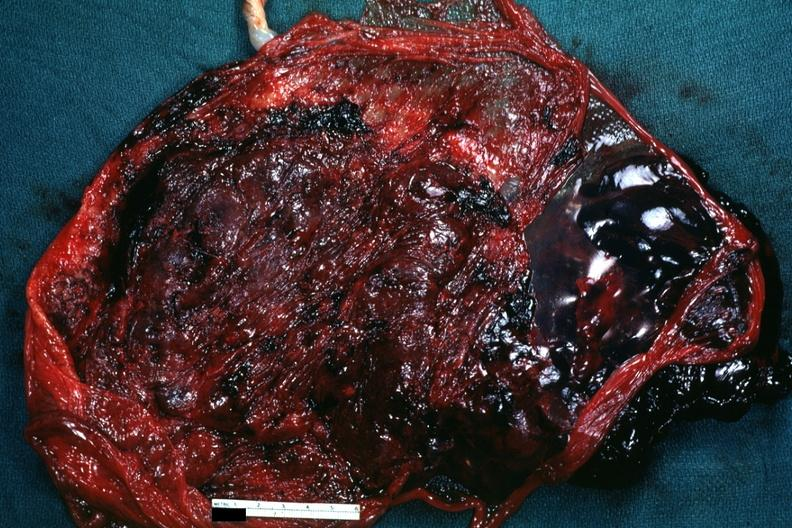s placenta present?
Answer the question using a single word or phrase. Yes 